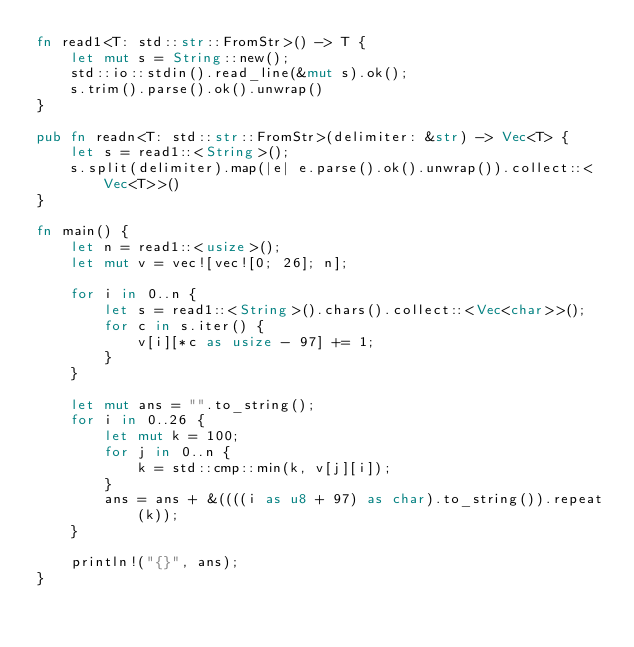<code> <loc_0><loc_0><loc_500><loc_500><_Rust_>fn read1<T: std::str::FromStr>() -> T {
    let mut s = String::new();
    std::io::stdin().read_line(&mut s).ok();
    s.trim().parse().ok().unwrap()
}

pub fn readn<T: std::str::FromStr>(delimiter: &str) -> Vec<T> {
    let s = read1::<String>();
    s.split(delimiter).map(|e| e.parse().ok().unwrap()).collect::<Vec<T>>()
}

fn main() {
    let n = read1::<usize>();
    let mut v = vec![vec![0; 26]; n];

    for i in 0..n {
        let s = read1::<String>().chars().collect::<Vec<char>>();
        for c in s.iter() {
            v[i][*c as usize - 97] += 1;
        }
    }

    let mut ans = "".to_string();
    for i in 0..26 {
        let mut k = 100;
        for j in 0..n {
            k = std::cmp::min(k, v[j][i]);
        }
        ans = ans + &((((i as u8 + 97) as char).to_string()).repeat(k));
    }

    println!("{}", ans);
}</code> 